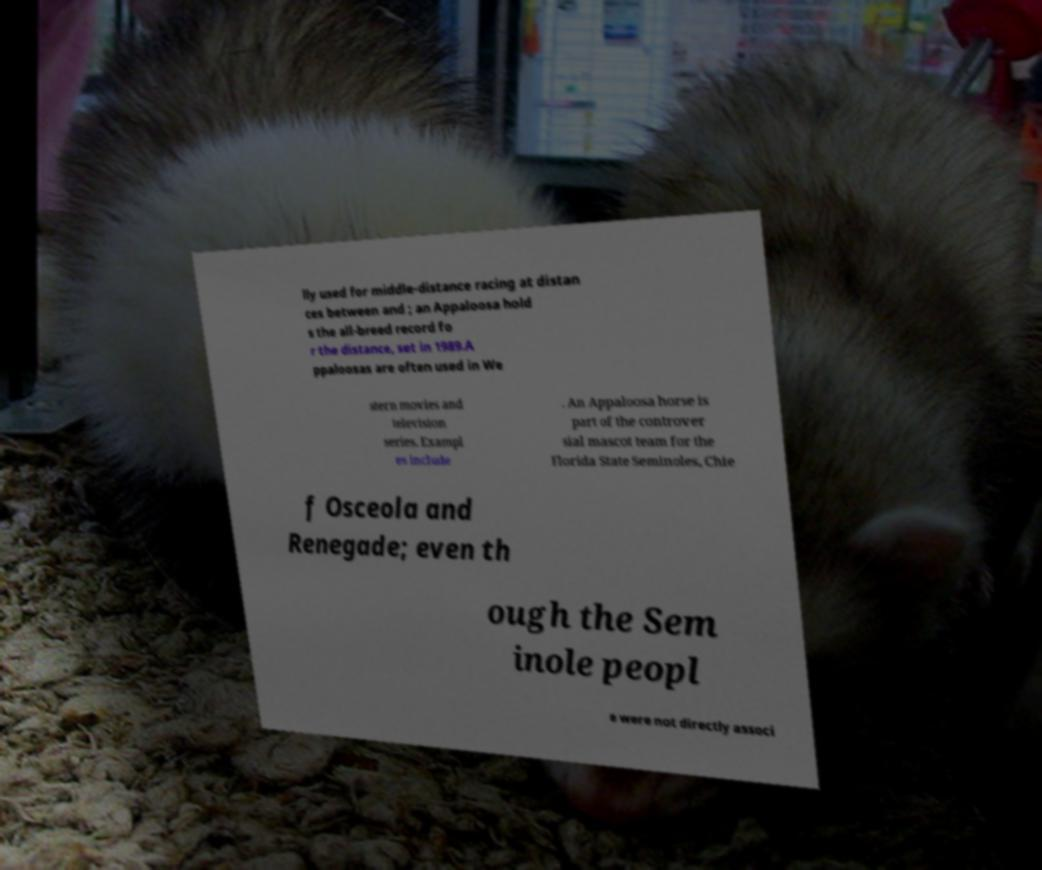Can you read and provide the text displayed in the image?This photo seems to have some interesting text. Can you extract and type it out for me? lly used for middle-distance racing at distan ces between and ; an Appaloosa hold s the all-breed record fo r the distance, set in 1989.A ppaloosas are often used in We stern movies and television series. Exampl es include . An Appaloosa horse is part of the controver sial mascot team for the Florida State Seminoles, Chie f Osceola and Renegade; even th ough the Sem inole peopl e were not directly associ 